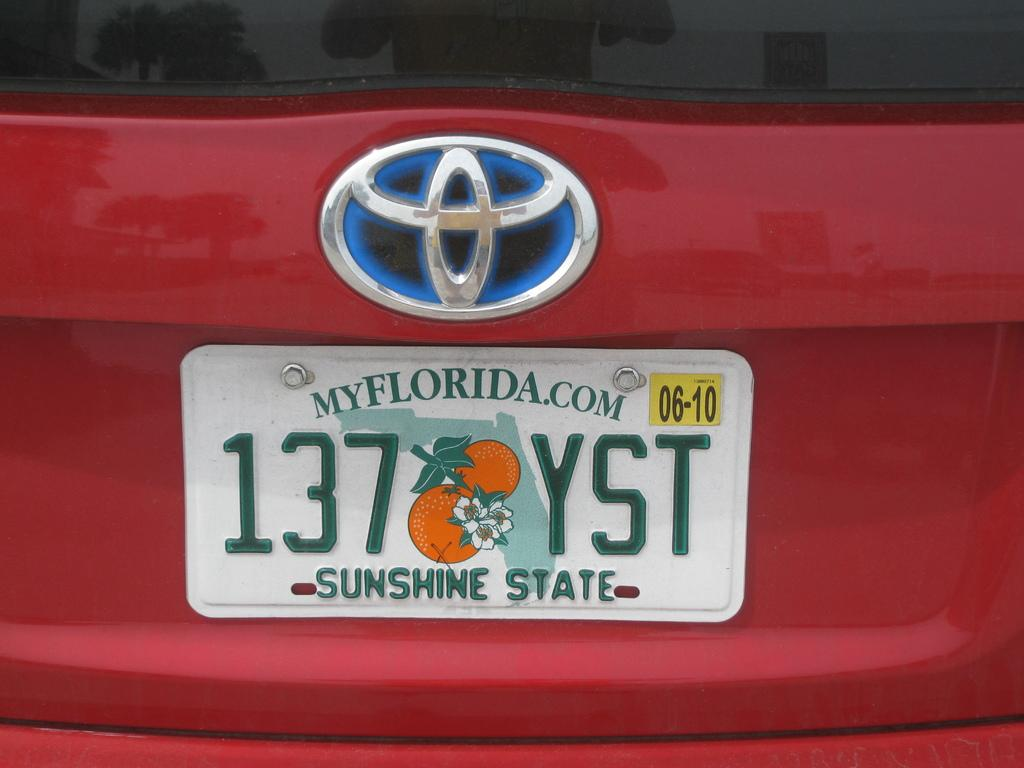Provide a one-sentence caption for the provided image. The wording on a Florida license plate on the back of a red toyota. 